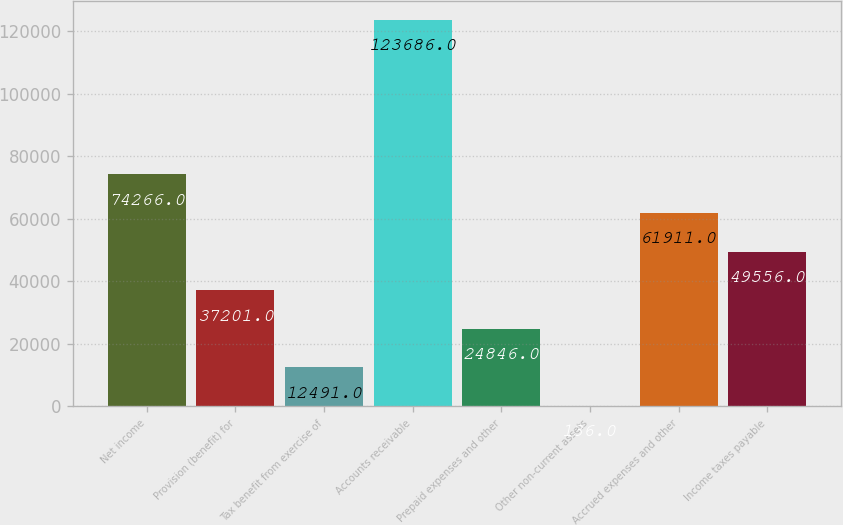Convert chart. <chart><loc_0><loc_0><loc_500><loc_500><bar_chart><fcel>Net income<fcel>Provision (benefit) for<fcel>Tax benefit from exercise of<fcel>Accounts receivable<fcel>Prepaid expenses and other<fcel>Other non-current assets<fcel>Accrued expenses and other<fcel>Income taxes payable<nl><fcel>74266<fcel>37201<fcel>12491<fcel>123686<fcel>24846<fcel>136<fcel>61911<fcel>49556<nl></chart> 